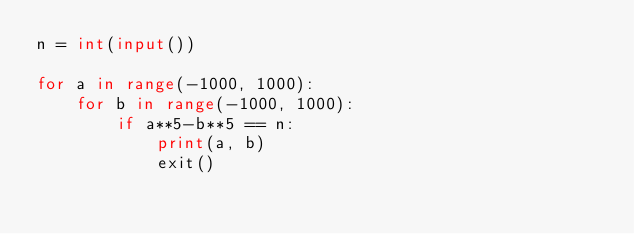Convert code to text. <code><loc_0><loc_0><loc_500><loc_500><_Python_>n = int(input())

for a in range(-1000, 1000):
    for b in range(-1000, 1000):
        if a**5-b**5 == n:
            print(a, b)
            exit()</code> 